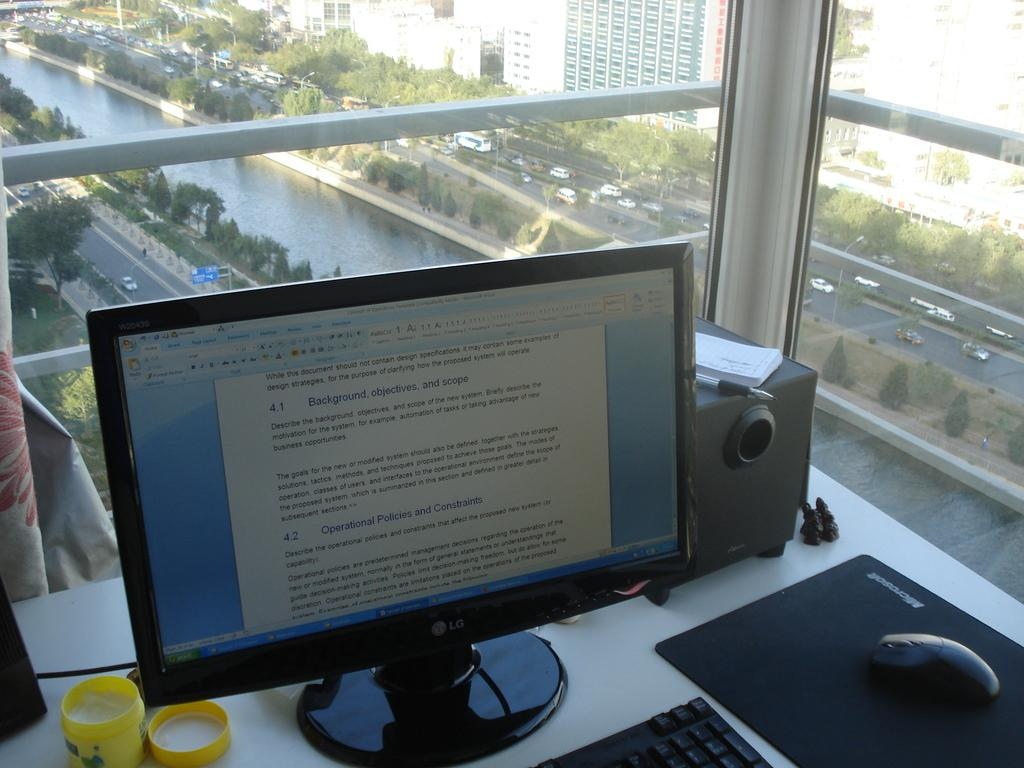<image>
Share a concise interpretation of the image provided. A computer desk with a document open that says Background, objectives, and scope. 